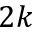Convert formula to latex. <formula><loc_0><loc_0><loc_500><loc_500>2 k</formula> 